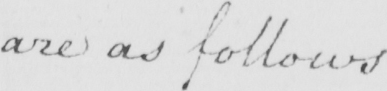Transcribe the text shown in this historical manuscript line. are as follows 